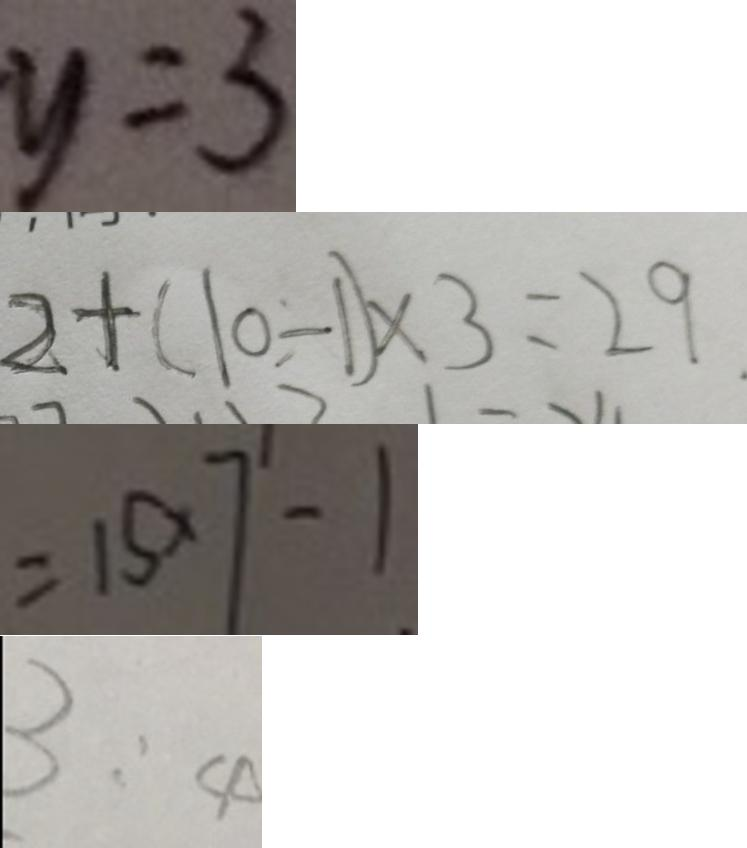Convert formula to latex. <formula><loc_0><loc_0><loc_500><loc_500>y = 3 
 2 + ( 1 0 - 1 ) \times 3 = 2 9 . 
 = 1 5 \times 7 - 1 
 3 : 4</formula> 